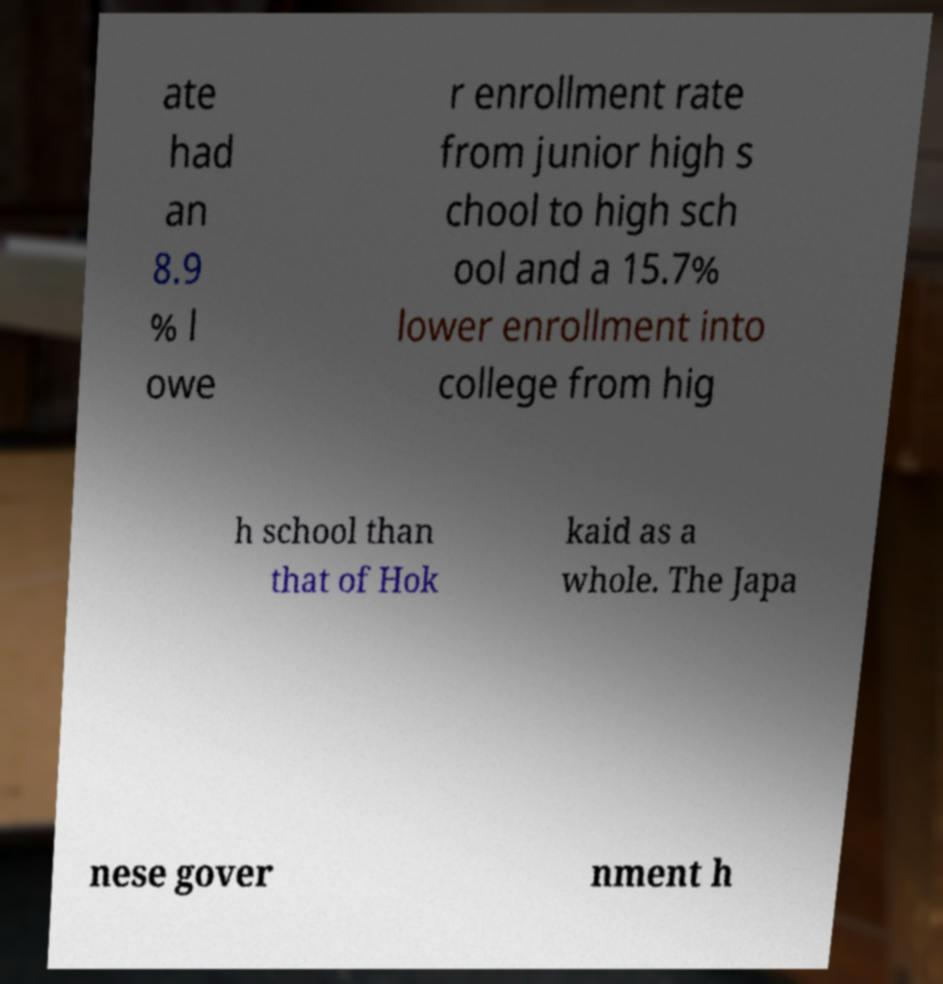Can you accurately transcribe the text from the provided image for me? ate had an 8.9 % l owe r enrollment rate from junior high s chool to high sch ool and a 15.7% lower enrollment into college from hig h school than that of Hok kaid as a whole. The Japa nese gover nment h 